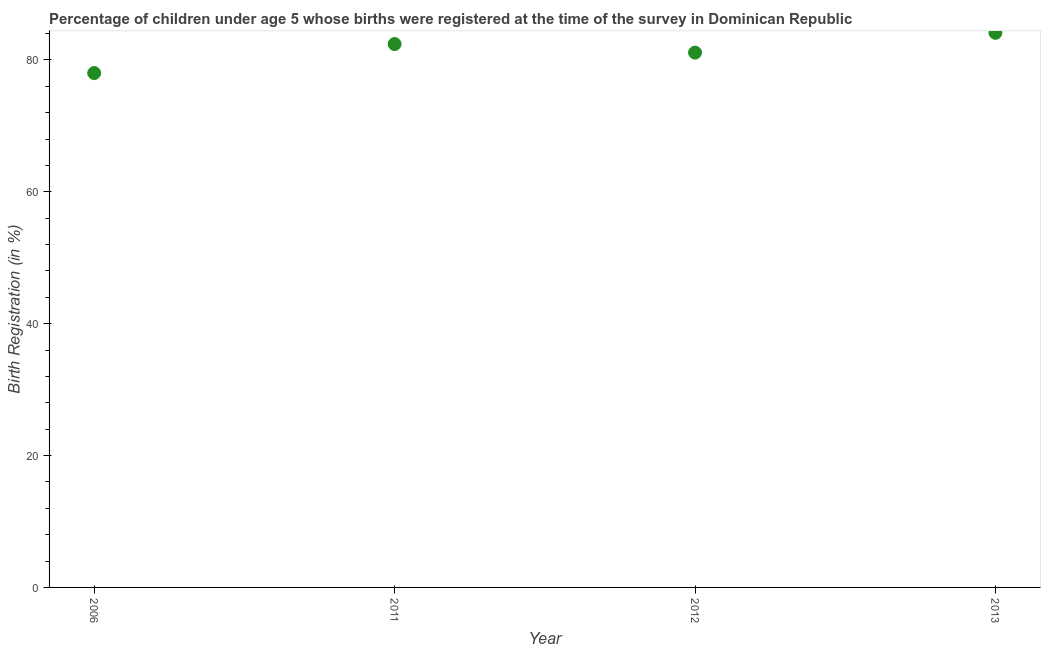What is the birth registration in 2011?
Provide a short and direct response. 82.4. Across all years, what is the maximum birth registration?
Provide a short and direct response. 84.1. Across all years, what is the minimum birth registration?
Make the answer very short. 78. In which year was the birth registration maximum?
Keep it short and to the point. 2013. What is the sum of the birth registration?
Provide a succinct answer. 325.6. What is the difference between the birth registration in 2006 and 2011?
Ensure brevity in your answer.  -4.4. What is the average birth registration per year?
Offer a very short reply. 81.4. What is the median birth registration?
Make the answer very short. 81.75. Do a majority of the years between 2012 and 2013 (inclusive) have birth registration greater than 72 %?
Provide a succinct answer. Yes. What is the ratio of the birth registration in 2006 to that in 2011?
Your answer should be compact. 0.95. Is the difference between the birth registration in 2006 and 2012 greater than the difference between any two years?
Offer a very short reply. No. What is the difference between the highest and the second highest birth registration?
Offer a very short reply. 1.7. Is the sum of the birth registration in 2011 and 2013 greater than the maximum birth registration across all years?
Give a very brief answer. Yes. What is the difference between the highest and the lowest birth registration?
Your answer should be compact. 6.1. In how many years, is the birth registration greater than the average birth registration taken over all years?
Your response must be concise. 2. How many dotlines are there?
Offer a terse response. 1. What is the difference between two consecutive major ticks on the Y-axis?
Ensure brevity in your answer.  20. Does the graph contain grids?
Make the answer very short. No. What is the title of the graph?
Provide a succinct answer. Percentage of children under age 5 whose births were registered at the time of the survey in Dominican Republic. What is the label or title of the Y-axis?
Ensure brevity in your answer.  Birth Registration (in %). What is the Birth Registration (in %) in 2006?
Give a very brief answer. 78. What is the Birth Registration (in %) in 2011?
Your answer should be compact. 82.4. What is the Birth Registration (in %) in 2012?
Offer a terse response. 81.1. What is the Birth Registration (in %) in 2013?
Offer a terse response. 84.1. What is the difference between the Birth Registration (in %) in 2006 and 2012?
Your answer should be very brief. -3.1. What is the difference between the Birth Registration (in %) in 2006 and 2013?
Your response must be concise. -6.1. What is the difference between the Birth Registration (in %) in 2011 and 2012?
Your answer should be compact. 1.3. What is the ratio of the Birth Registration (in %) in 2006 to that in 2011?
Keep it short and to the point. 0.95. What is the ratio of the Birth Registration (in %) in 2006 to that in 2013?
Make the answer very short. 0.93. What is the ratio of the Birth Registration (in %) in 2011 to that in 2012?
Offer a very short reply. 1.02. 